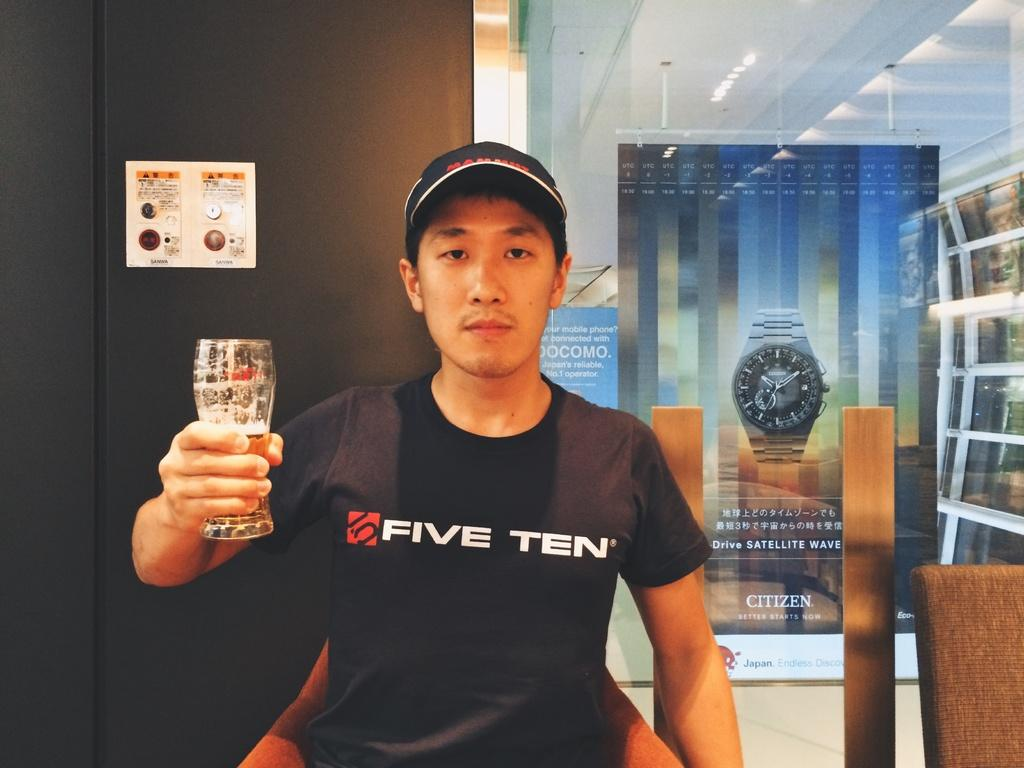<image>
Describe the image concisely. A man wears a shirt that says "FIVE TEN." 